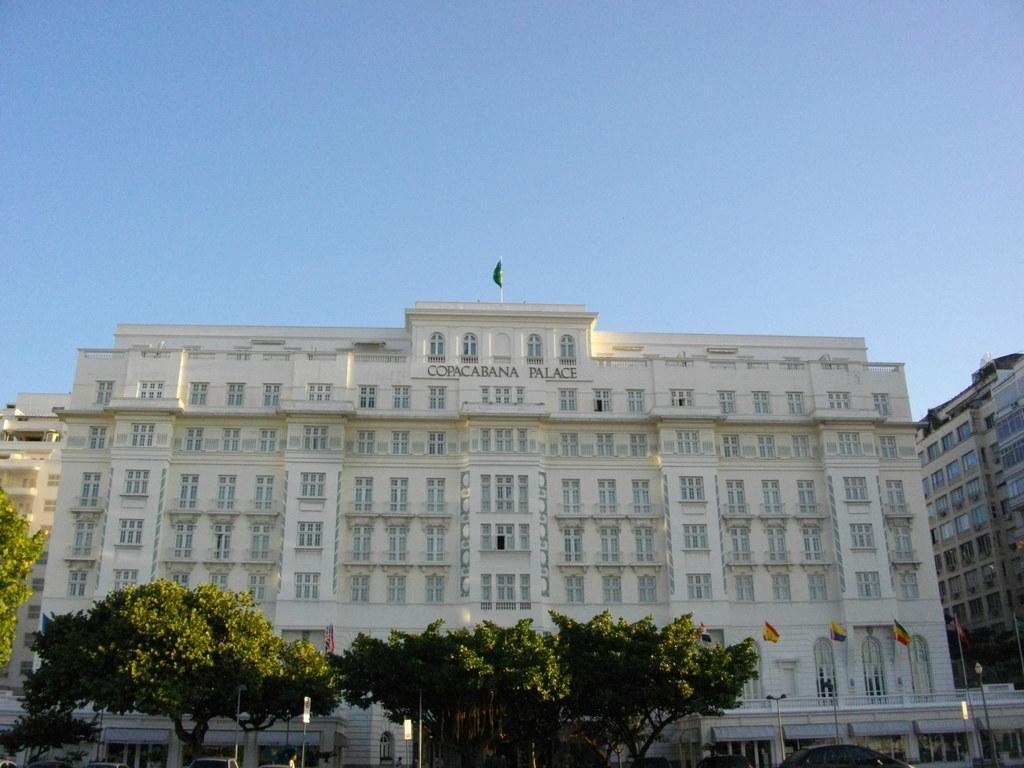Describe this image in one or two sentences. In this picture we can see few buildings, in front of the buildings we can find few trees, flags and vehicles. 